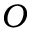Convert formula to latex. <formula><loc_0><loc_0><loc_500><loc_500>O</formula> 